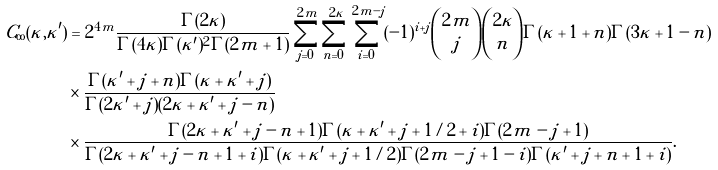<formula> <loc_0><loc_0><loc_500><loc_500>C _ { \infty } ( \kappa , \kappa ^ { \prime } ) & = 2 ^ { 4 m } \frac { \Gamma ( 2 \kappa ) } { \Gamma ( 4 \kappa ) \Gamma ( \kappa ^ { \prime } ) ^ { 2 } \Gamma ( 2 m + 1 ) } \sum _ { j = 0 } ^ { 2 m } \sum _ { n = 0 } ^ { 2 \kappa } \sum _ { i = 0 } ^ { 2 m - j } ( - 1 ) ^ { i + j } { 2 m \choose j } { 2 \kappa \choose n } \Gamma ( \kappa + 1 + n ) \Gamma ( 3 \kappa + 1 - n ) \\ & \times \frac { \Gamma ( \kappa ^ { \prime } + j + n ) \Gamma ( \kappa + \kappa ^ { \prime } + j ) } { \Gamma ( 2 \kappa ^ { \prime } + j ) ( 2 \kappa + \kappa ^ { \prime } + j - n ) } \\ & \times \frac { \Gamma ( 2 \kappa + \kappa ^ { \prime } + j - n + 1 ) \Gamma ( \kappa + \kappa ^ { \prime } + j + 1 / 2 + i ) \Gamma ( 2 m - j + 1 ) } { \Gamma ( 2 \kappa + \kappa ^ { \prime } + j - n + 1 + i ) \Gamma ( \kappa + \kappa ^ { \prime } + j + 1 / 2 ) \Gamma ( 2 m - j + 1 - i ) \Gamma ( \kappa ^ { \prime } + j + n + 1 + i ) } .</formula> 